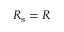Convert formula to latex. <formula><loc_0><loc_0><loc_500><loc_500>R _ { s } = R</formula> 